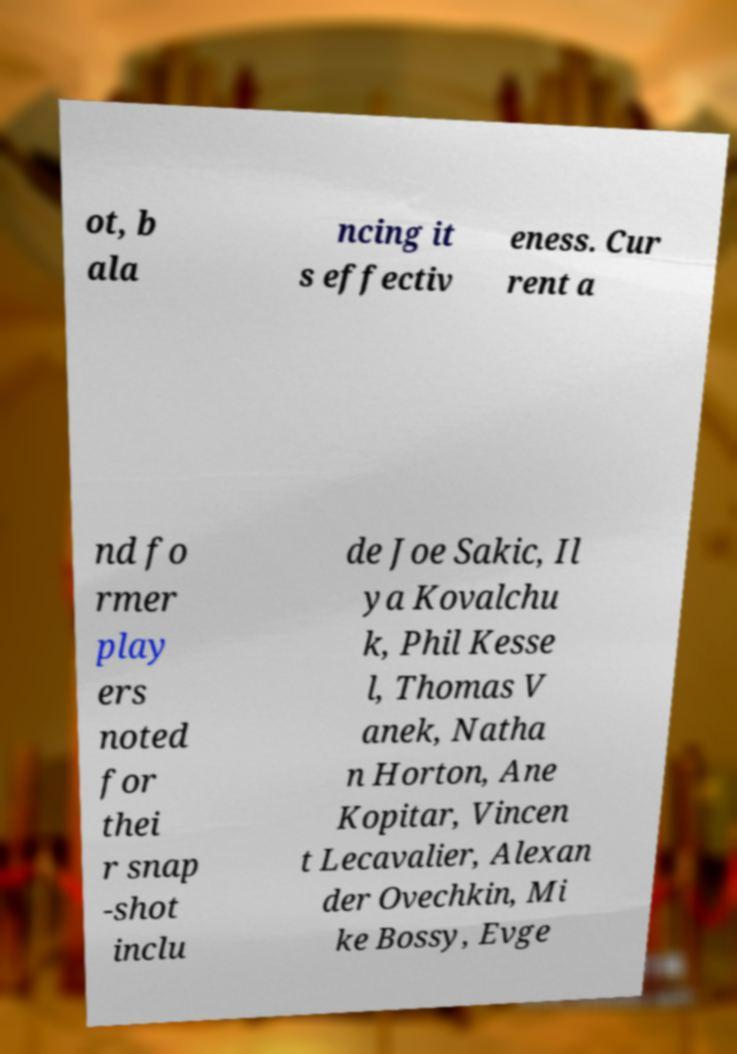Can you accurately transcribe the text from the provided image for me? ot, b ala ncing it s effectiv eness. Cur rent a nd fo rmer play ers noted for thei r snap -shot inclu de Joe Sakic, Il ya Kovalchu k, Phil Kesse l, Thomas V anek, Natha n Horton, Ane Kopitar, Vincen t Lecavalier, Alexan der Ovechkin, Mi ke Bossy, Evge 